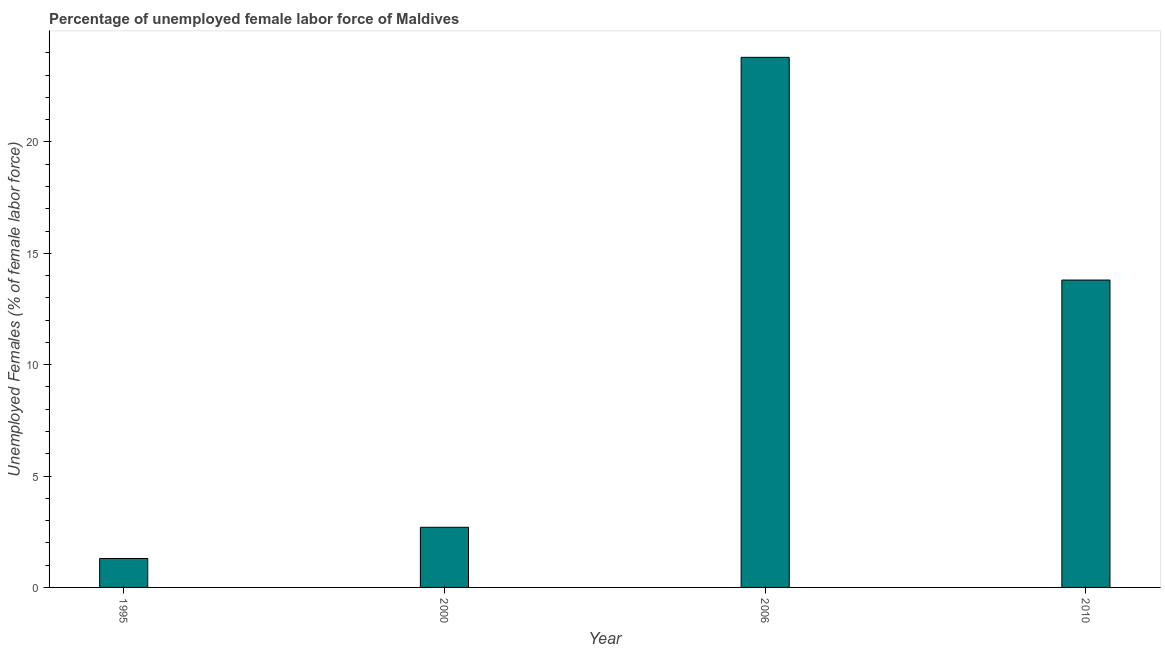What is the title of the graph?
Your answer should be compact. Percentage of unemployed female labor force of Maldives. What is the label or title of the X-axis?
Your response must be concise. Year. What is the label or title of the Y-axis?
Offer a very short reply. Unemployed Females (% of female labor force). What is the total unemployed female labour force in 2000?
Provide a short and direct response. 2.7. Across all years, what is the maximum total unemployed female labour force?
Your response must be concise. 23.8. Across all years, what is the minimum total unemployed female labour force?
Ensure brevity in your answer.  1.3. In which year was the total unemployed female labour force maximum?
Make the answer very short. 2006. What is the sum of the total unemployed female labour force?
Keep it short and to the point. 41.6. What is the difference between the total unemployed female labour force in 2000 and 2006?
Provide a short and direct response. -21.1. What is the average total unemployed female labour force per year?
Give a very brief answer. 10.4. What is the median total unemployed female labour force?
Provide a succinct answer. 8.25. Do a majority of the years between 2000 and 1995 (inclusive) have total unemployed female labour force greater than 8 %?
Your answer should be compact. No. What is the ratio of the total unemployed female labour force in 2000 to that in 2006?
Give a very brief answer. 0.11. Is the total unemployed female labour force in 2000 less than that in 2006?
Keep it short and to the point. Yes. What is the difference between the highest and the second highest total unemployed female labour force?
Keep it short and to the point. 10. Is the sum of the total unemployed female labour force in 1995 and 2010 greater than the maximum total unemployed female labour force across all years?
Ensure brevity in your answer.  No. What is the difference between the highest and the lowest total unemployed female labour force?
Your answer should be very brief. 22.5. How many bars are there?
Keep it short and to the point. 4. Are the values on the major ticks of Y-axis written in scientific E-notation?
Give a very brief answer. No. What is the Unemployed Females (% of female labor force) in 1995?
Provide a short and direct response. 1.3. What is the Unemployed Females (% of female labor force) of 2000?
Make the answer very short. 2.7. What is the Unemployed Females (% of female labor force) in 2006?
Give a very brief answer. 23.8. What is the Unemployed Females (% of female labor force) in 2010?
Your response must be concise. 13.8. What is the difference between the Unemployed Females (% of female labor force) in 1995 and 2006?
Provide a succinct answer. -22.5. What is the difference between the Unemployed Females (% of female labor force) in 1995 and 2010?
Your answer should be compact. -12.5. What is the difference between the Unemployed Females (% of female labor force) in 2000 and 2006?
Offer a terse response. -21.1. What is the difference between the Unemployed Females (% of female labor force) in 2000 and 2010?
Provide a succinct answer. -11.1. What is the ratio of the Unemployed Females (% of female labor force) in 1995 to that in 2000?
Offer a very short reply. 0.48. What is the ratio of the Unemployed Females (% of female labor force) in 1995 to that in 2006?
Your answer should be compact. 0.06. What is the ratio of the Unemployed Females (% of female labor force) in 1995 to that in 2010?
Give a very brief answer. 0.09. What is the ratio of the Unemployed Females (% of female labor force) in 2000 to that in 2006?
Offer a terse response. 0.11. What is the ratio of the Unemployed Females (% of female labor force) in 2000 to that in 2010?
Your answer should be compact. 0.2. What is the ratio of the Unemployed Females (% of female labor force) in 2006 to that in 2010?
Provide a short and direct response. 1.73. 